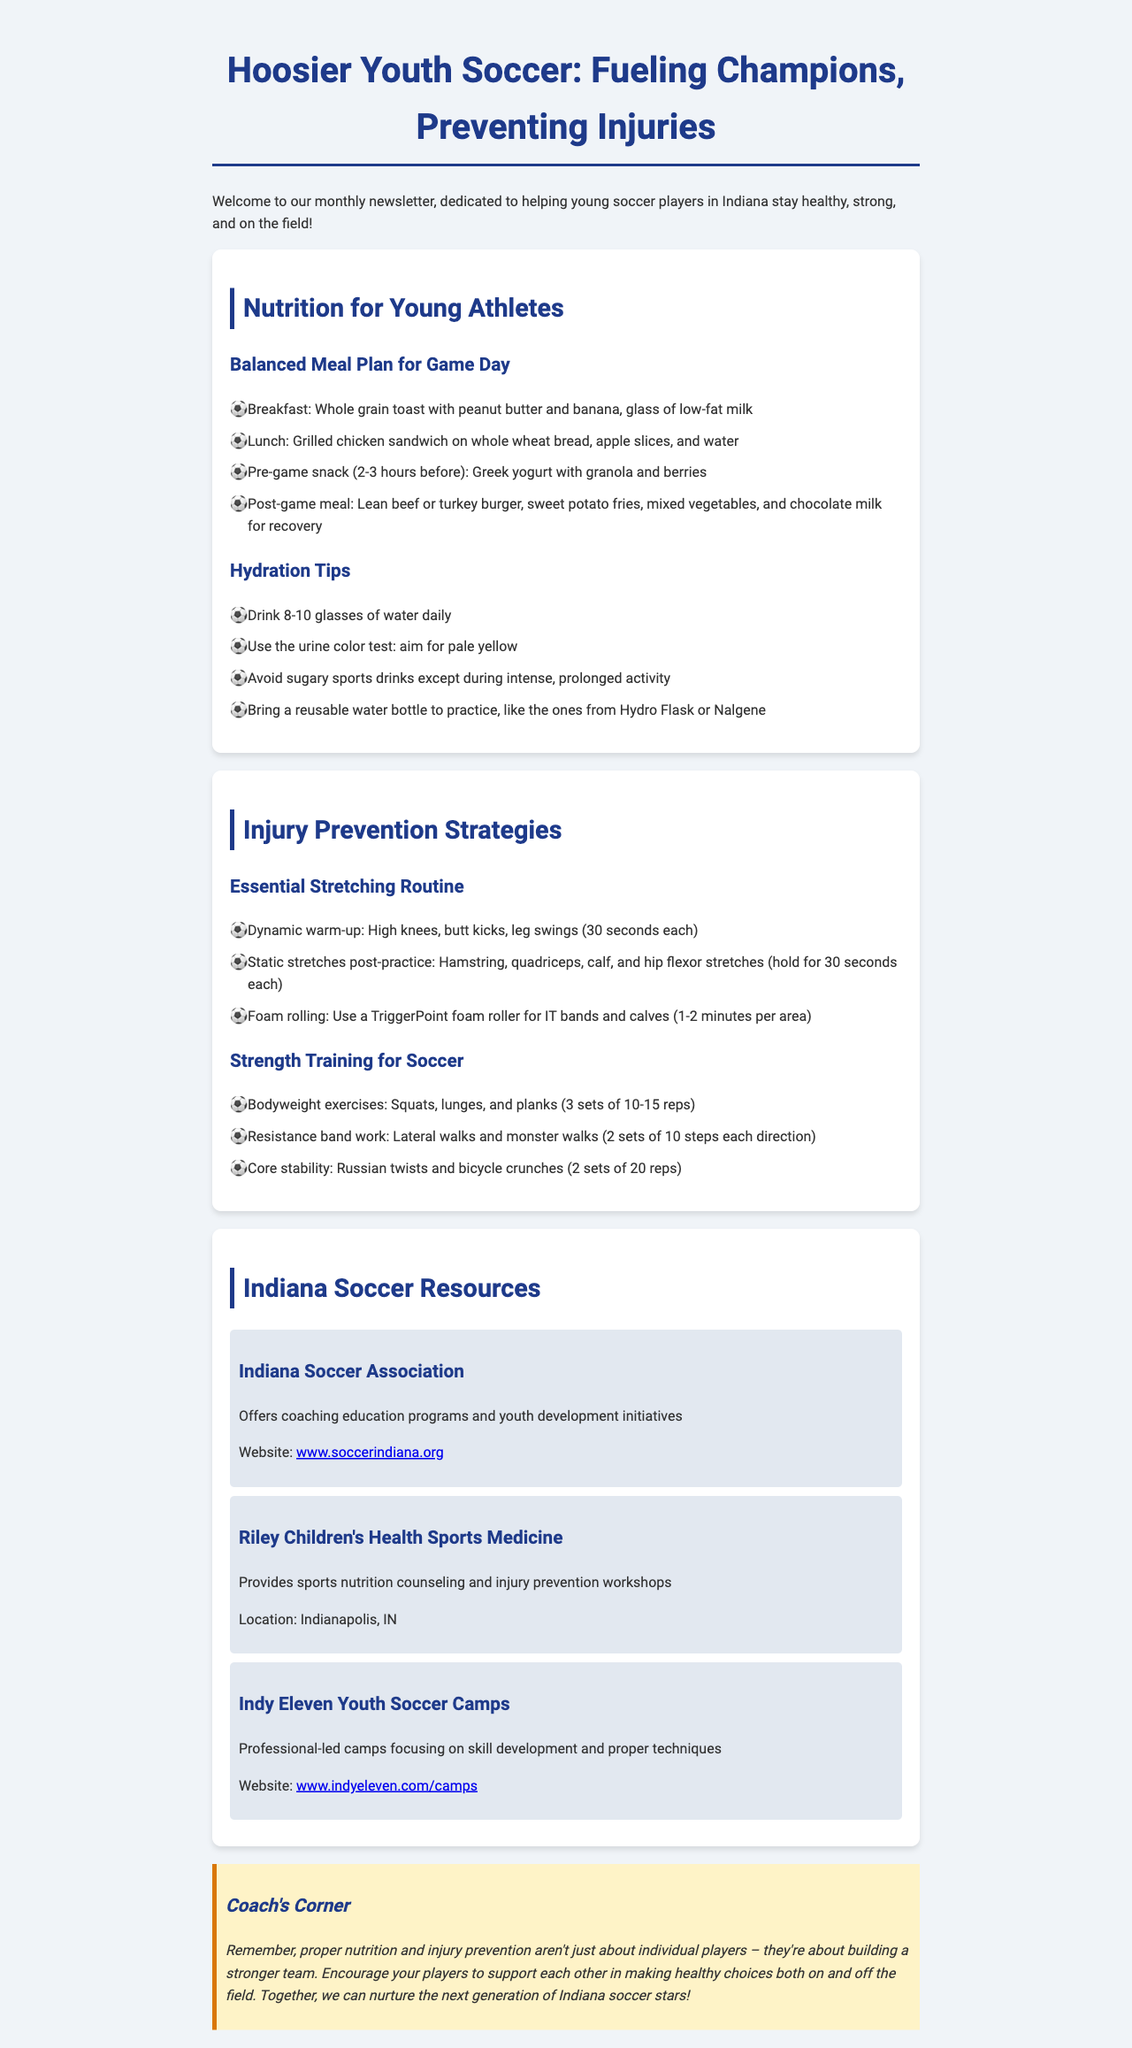What is the title of the newsletter? The title of the newsletter is stated at the beginning of the document.
Answer: Hoosier Youth Soccer: Fueling Champions, Preventing Injuries What is suggested for breakfast? The breakfast suggestion is found in the balanced meal plan section of the document.
Answer: Whole grain toast with peanut butter and banana, glass of low-fat milk How many glasses of water should young athletes drink daily? The hydration tips section provides specific guidance on daily water intake.
Answer: 8-10 glasses What is the recommended duration for holding static stretches? The essential stretching routine section specifies the duration for static stretches.
Answer: 30 seconds What are two bodyweight exercises mentioned in the strength training section? The strength training section lists specific exercises young athletes can perform.
Answer: Squats, lunges What type of workshops does Riley Children's Health Sports Medicine provide? The local resources section includes details on the workshops available from this organization.
Answer: Injury prevention workshops What color of urine indicates proper hydration? The hydration tips section provides information about the urine color test.
Answer: Pale yellow What kind of stretches are recommended post-practice? The essential stretching routine includes details about what to do after practice.
Answer: Hamstring, quadriceps, calf, and hip flexor stretches What is the primary focus of the Indiana Soccer Association? The local resources section describes the focus of the Indiana Soccer Association.
Answer: Coaching education programs and youth development initiatives 